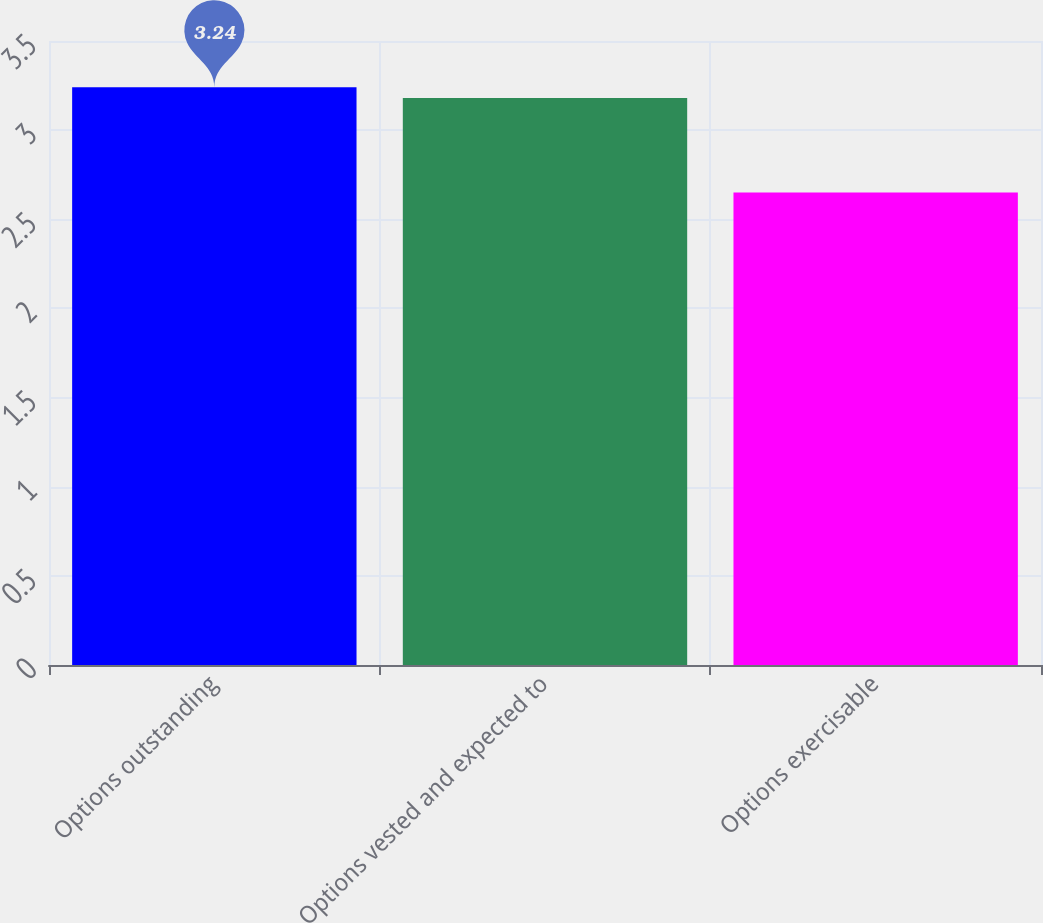<chart> <loc_0><loc_0><loc_500><loc_500><bar_chart><fcel>Options outstanding<fcel>Options vested and expected to<fcel>Options exercisable<nl><fcel>3.24<fcel>3.18<fcel>2.65<nl></chart> 